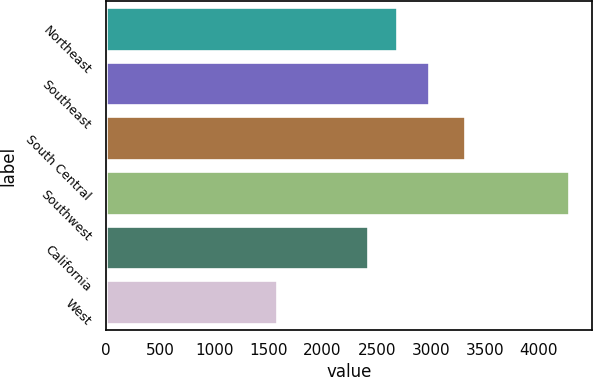<chart> <loc_0><loc_0><loc_500><loc_500><bar_chart><fcel>Northeast<fcel>Southeast<fcel>South Central<fcel>Southwest<fcel>California<fcel>West<nl><fcel>2692.5<fcel>2980<fcel>3321<fcel>4279<fcel>2422<fcel>1574<nl></chart> 